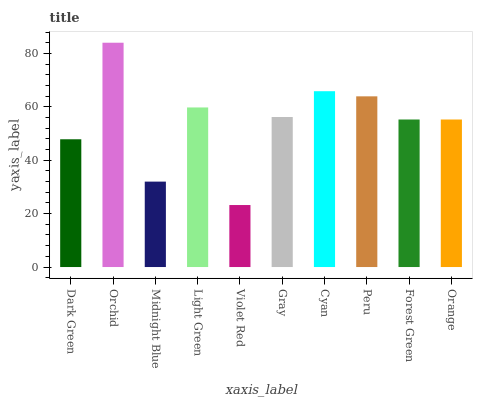Is Violet Red the minimum?
Answer yes or no. Yes. Is Orchid the maximum?
Answer yes or no. Yes. Is Midnight Blue the minimum?
Answer yes or no. No. Is Midnight Blue the maximum?
Answer yes or no. No. Is Orchid greater than Midnight Blue?
Answer yes or no. Yes. Is Midnight Blue less than Orchid?
Answer yes or no. Yes. Is Midnight Blue greater than Orchid?
Answer yes or no. No. Is Orchid less than Midnight Blue?
Answer yes or no. No. Is Gray the high median?
Answer yes or no. Yes. Is Forest Green the low median?
Answer yes or no. Yes. Is Violet Red the high median?
Answer yes or no. No. Is Peru the low median?
Answer yes or no. No. 